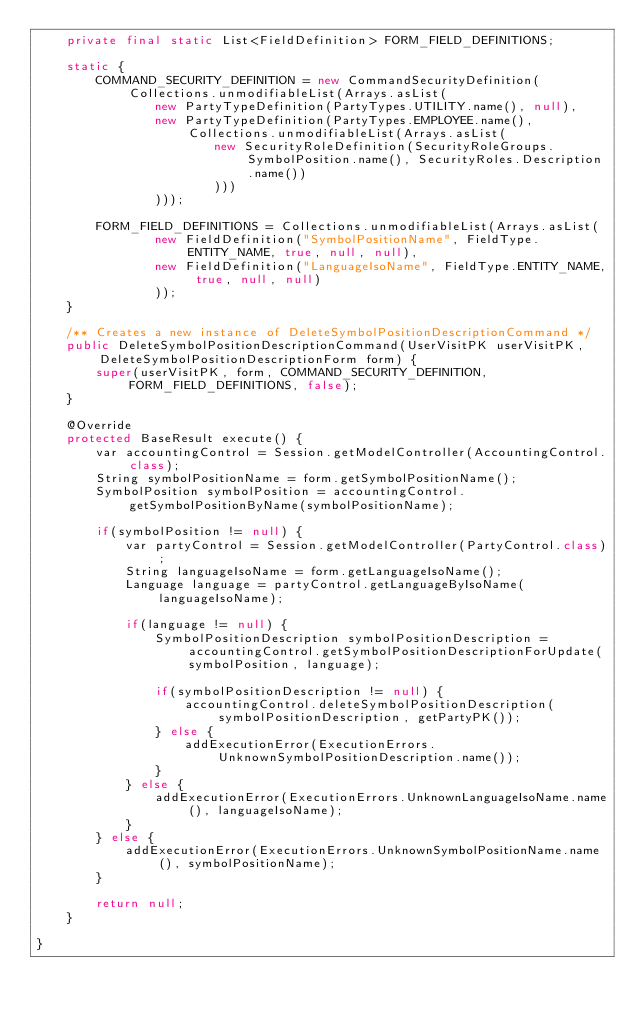Convert code to text. <code><loc_0><loc_0><loc_500><loc_500><_Java_>    private final static List<FieldDefinition> FORM_FIELD_DEFINITIONS;
    
    static {
        COMMAND_SECURITY_DEFINITION = new CommandSecurityDefinition(Collections.unmodifiableList(Arrays.asList(
                new PartyTypeDefinition(PartyTypes.UTILITY.name(), null),
                new PartyTypeDefinition(PartyTypes.EMPLOYEE.name(), Collections.unmodifiableList(Arrays.asList(
                        new SecurityRoleDefinition(SecurityRoleGroups.SymbolPosition.name(), SecurityRoles.Description.name())
                        )))
                )));
        
        FORM_FIELD_DEFINITIONS = Collections.unmodifiableList(Arrays.asList(
                new FieldDefinition("SymbolPositionName", FieldType.ENTITY_NAME, true, null, null),
                new FieldDefinition("LanguageIsoName", FieldType.ENTITY_NAME, true, null, null)
                ));
    }
    
    /** Creates a new instance of DeleteSymbolPositionDescriptionCommand */
    public DeleteSymbolPositionDescriptionCommand(UserVisitPK userVisitPK, DeleteSymbolPositionDescriptionForm form) {
        super(userVisitPK, form, COMMAND_SECURITY_DEFINITION, FORM_FIELD_DEFINITIONS, false);
    }
    
    @Override
    protected BaseResult execute() {
        var accountingControl = Session.getModelController(AccountingControl.class);
        String symbolPositionName = form.getSymbolPositionName();
        SymbolPosition symbolPosition = accountingControl.getSymbolPositionByName(symbolPositionName);
        
        if(symbolPosition != null) {
            var partyControl = Session.getModelController(PartyControl.class);
            String languageIsoName = form.getLanguageIsoName();
            Language language = partyControl.getLanguageByIsoName(languageIsoName);
            
            if(language != null) {
                SymbolPositionDescription symbolPositionDescription = accountingControl.getSymbolPositionDescriptionForUpdate(symbolPosition, language);
                
                if(symbolPositionDescription != null) {
                    accountingControl.deleteSymbolPositionDescription(symbolPositionDescription, getPartyPK());
                } else {
                    addExecutionError(ExecutionErrors.UnknownSymbolPositionDescription.name());
                }
            } else {
                addExecutionError(ExecutionErrors.UnknownLanguageIsoName.name(), languageIsoName);
            }
        } else {
            addExecutionError(ExecutionErrors.UnknownSymbolPositionName.name(), symbolPositionName);
        }
        
        return null;
    }
    
}
</code> 